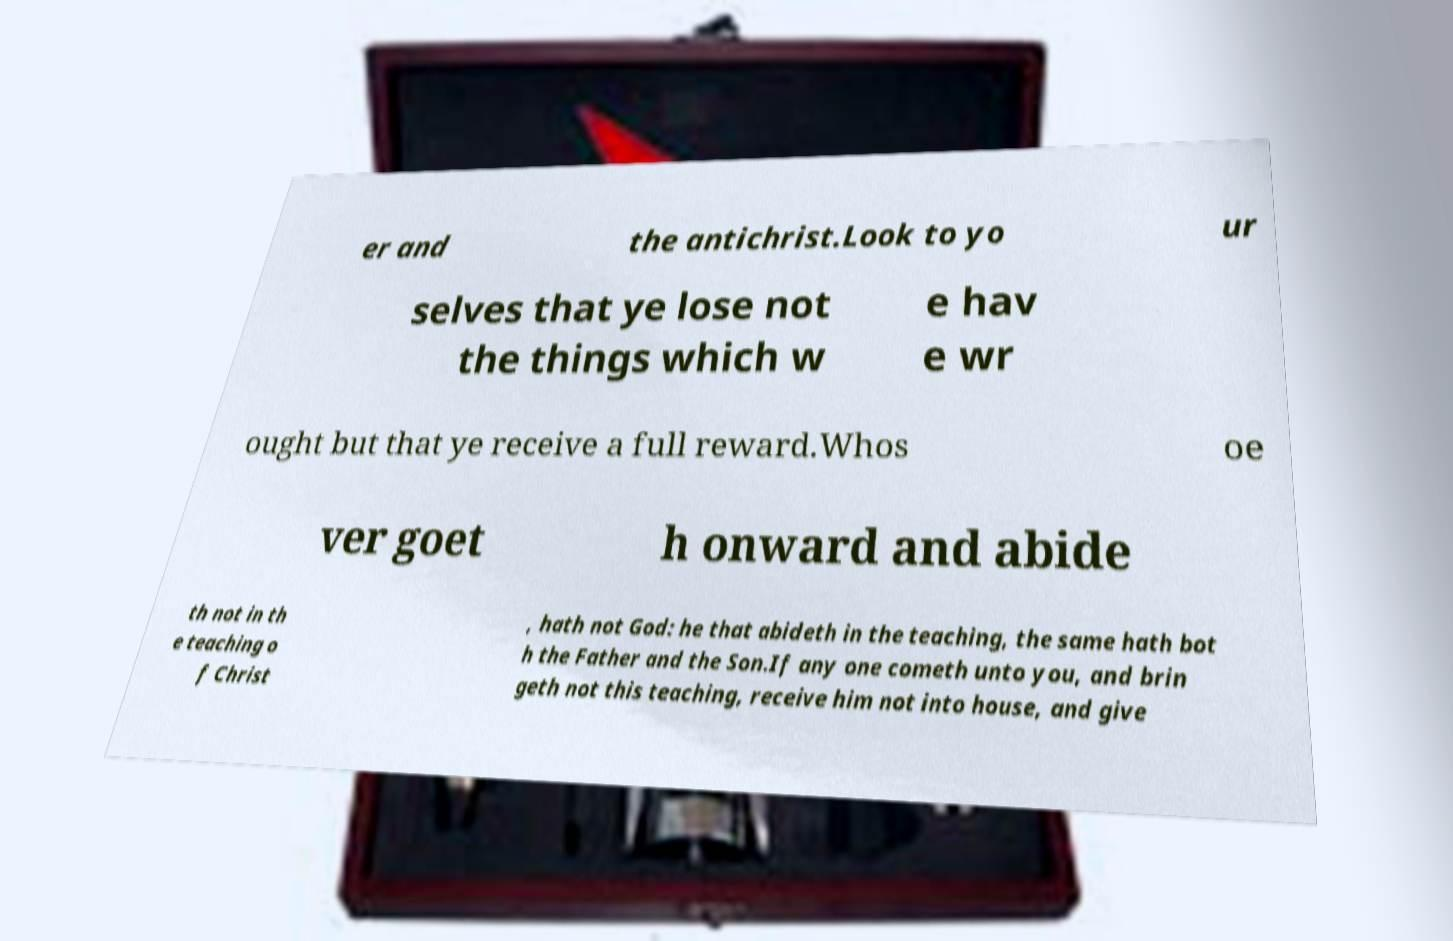Can you read and provide the text displayed in the image?This photo seems to have some interesting text. Can you extract and type it out for me? er and the antichrist.Look to yo ur selves that ye lose not the things which w e hav e wr ought but that ye receive a full reward.Whos oe ver goet h onward and abide th not in th e teaching o f Christ , hath not God: he that abideth in the teaching, the same hath bot h the Father and the Son.If any one cometh unto you, and brin geth not this teaching, receive him not into house, and give 